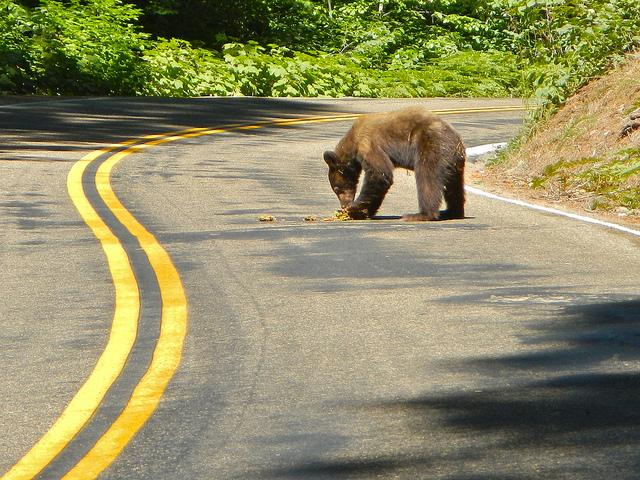What color are the lines on the street?
Concise answer only. Yellow. Is this a dangerous place for a bear?
Give a very brief answer. Yes. Is than an adult bear?
Concise answer only. Yes. 